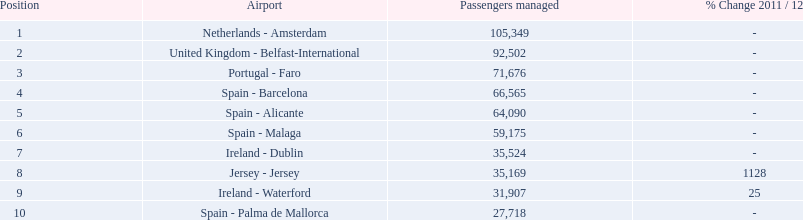Which airports are in europe? Netherlands - Amsterdam, United Kingdom - Belfast-International, Portugal - Faro, Spain - Barcelona, Spain - Alicante, Spain - Malaga, Ireland - Dublin, Ireland - Waterford, Spain - Palma de Mallorca. Which one is from portugal? Portugal - Faro. 